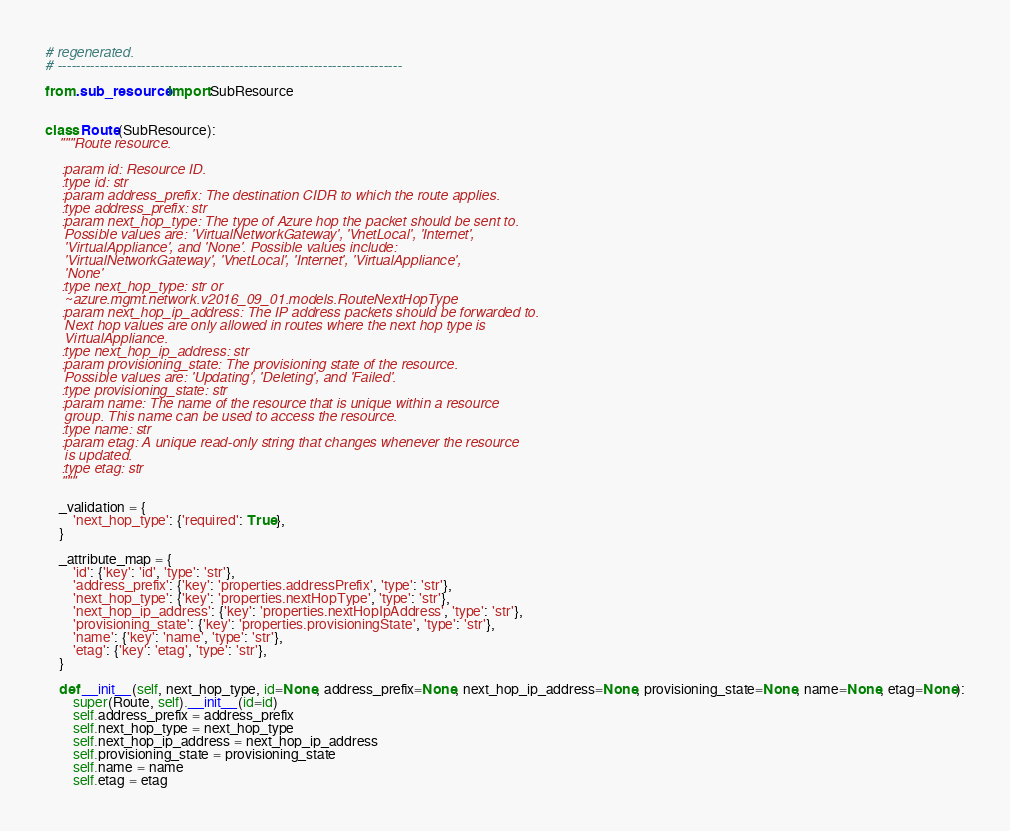<code> <loc_0><loc_0><loc_500><loc_500><_Python_># regenerated.
# --------------------------------------------------------------------------

from .sub_resource import SubResource


class Route(SubResource):
    """Route resource.

    :param id: Resource ID.
    :type id: str
    :param address_prefix: The destination CIDR to which the route applies.
    :type address_prefix: str
    :param next_hop_type: The type of Azure hop the packet should be sent to.
     Possible values are: 'VirtualNetworkGateway', 'VnetLocal', 'Internet',
     'VirtualAppliance', and 'None'. Possible values include:
     'VirtualNetworkGateway', 'VnetLocal', 'Internet', 'VirtualAppliance',
     'None'
    :type next_hop_type: str or
     ~azure.mgmt.network.v2016_09_01.models.RouteNextHopType
    :param next_hop_ip_address: The IP address packets should be forwarded to.
     Next hop values are only allowed in routes where the next hop type is
     VirtualAppliance.
    :type next_hop_ip_address: str
    :param provisioning_state: The provisioning state of the resource.
     Possible values are: 'Updating', 'Deleting', and 'Failed'.
    :type provisioning_state: str
    :param name: The name of the resource that is unique within a resource
     group. This name can be used to access the resource.
    :type name: str
    :param etag: A unique read-only string that changes whenever the resource
     is updated.
    :type etag: str
    """

    _validation = {
        'next_hop_type': {'required': True},
    }

    _attribute_map = {
        'id': {'key': 'id', 'type': 'str'},
        'address_prefix': {'key': 'properties.addressPrefix', 'type': 'str'},
        'next_hop_type': {'key': 'properties.nextHopType', 'type': 'str'},
        'next_hop_ip_address': {'key': 'properties.nextHopIpAddress', 'type': 'str'},
        'provisioning_state': {'key': 'properties.provisioningState', 'type': 'str'},
        'name': {'key': 'name', 'type': 'str'},
        'etag': {'key': 'etag', 'type': 'str'},
    }

    def __init__(self, next_hop_type, id=None, address_prefix=None, next_hop_ip_address=None, provisioning_state=None, name=None, etag=None):
        super(Route, self).__init__(id=id)
        self.address_prefix = address_prefix
        self.next_hop_type = next_hop_type
        self.next_hop_ip_address = next_hop_ip_address
        self.provisioning_state = provisioning_state
        self.name = name
        self.etag = etag
</code> 